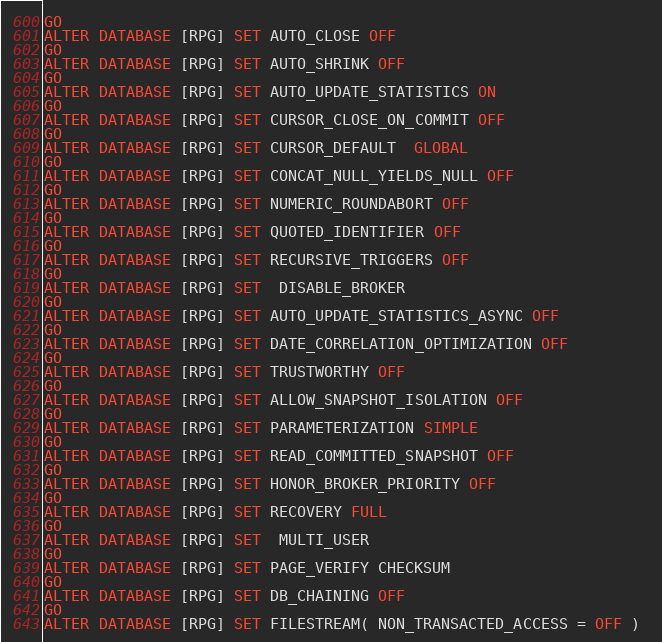Convert code to text. <code><loc_0><loc_0><loc_500><loc_500><_SQL_>GO
ALTER DATABASE [RPG] SET AUTO_CLOSE OFF 
GO
ALTER DATABASE [RPG] SET AUTO_SHRINK OFF 
GO
ALTER DATABASE [RPG] SET AUTO_UPDATE_STATISTICS ON 
GO
ALTER DATABASE [RPG] SET CURSOR_CLOSE_ON_COMMIT OFF 
GO
ALTER DATABASE [RPG] SET CURSOR_DEFAULT  GLOBAL 
GO
ALTER DATABASE [RPG] SET CONCAT_NULL_YIELDS_NULL OFF 
GO
ALTER DATABASE [RPG] SET NUMERIC_ROUNDABORT OFF 
GO
ALTER DATABASE [RPG] SET QUOTED_IDENTIFIER OFF 
GO
ALTER DATABASE [RPG] SET RECURSIVE_TRIGGERS OFF 
GO
ALTER DATABASE [RPG] SET  DISABLE_BROKER 
GO
ALTER DATABASE [RPG] SET AUTO_UPDATE_STATISTICS_ASYNC OFF 
GO
ALTER DATABASE [RPG] SET DATE_CORRELATION_OPTIMIZATION OFF 
GO
ALTER DATABASE [RPG] SET TRUSTWORTHY OFF 
GO
ALTER DATABASE [RPG] SET ALLOW_SNAPSHOT_ISOLATION OFF 
GO
ALTER DATABASE [RPG] SET PARAMETERIZATION SIMPLE 
GO
ALTER DATABASE [RPG] SET READ_COMMITTED_SNAPSHOT OFF 
GO
ALTER DATABASE [RPG] SET HONOR_BROKER_PRIORITY OFF 
GO
ALTER DATABASE [RPG] SET RECOVERY FULL 
GO
ALTER DATABASE [RPG] SET  MULTI_USER 
GO
ALTER DATABASE [RPG] SET PAGE_VERIFY CHECKSUM  
GO
ALTER DATABASE [RPG] SET DB_CHAINING OFF 
GO
ALTER DATABASE [RPG] SET FILESTREAM( NON_TRANSACTED_ACCESS = OFF ) </code> 